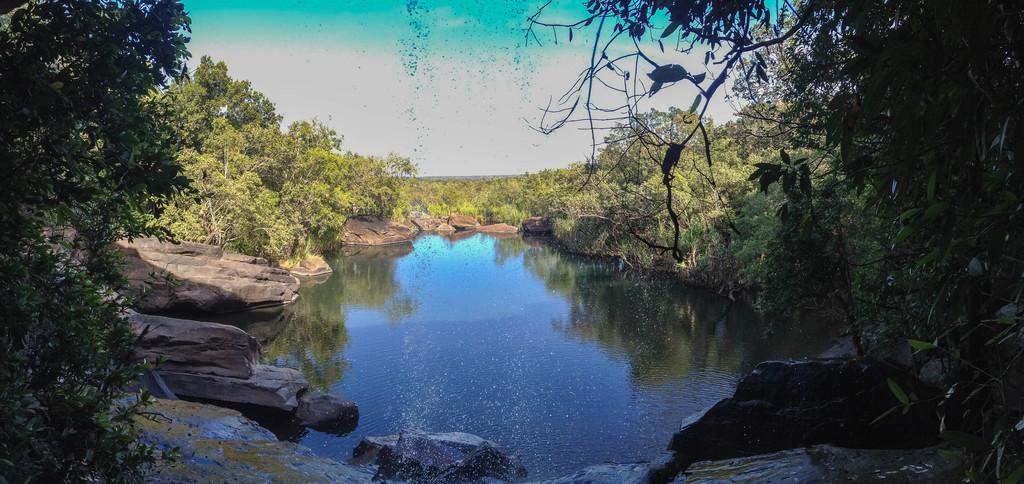What type of vegetation can be seen in the image? There are trees in the image. What other natural elements are present in the image? There are rocks and water visible in the image. What is visible at the top of the image? The sky is visible at the top of the image. What can be seen in the sky? There are clouds in the sky. What is reflected on the water in the image? There are reflections of trees on the water. What verse is being recited by the mother in the image? There is no mother or verse present in the image. What type of patch can be seen on the trees in the image? There are no patches visible on the trees in the image. 